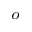Convert formula to latex. <formula><loc_0><loc_0><loc_500><loc_500>^ { o }</formula> 